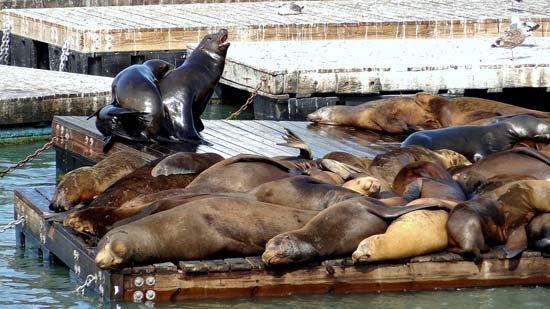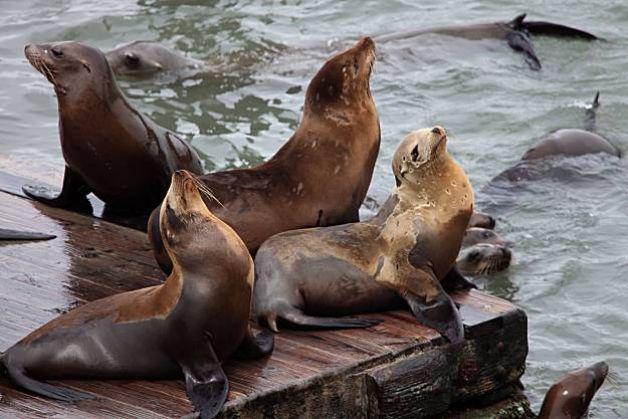The first image is the image on the left, the second image is the image on the right. Assess this claim about the two images: "A seal's head shows above the water in front of a floating platform packed with seals, in the left image.". Correct or not? Answer yes or no. No. The first image is the image on the left, the second image is the image on the right. Analyze the images presented: Is the assertion "There are at most two sea lions swimming in water." valid? Answer yes or no. No. 